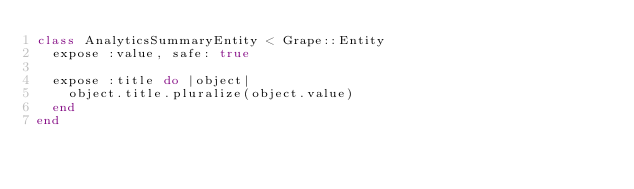Convert code to text. <code><loc_0><loc_0><loc_500><loc_500><_Ruby_>class AnalyticsSummaryEntity < Grape::Entity
  expose :value, safe: true

  expose :title do |object|
    object.title.pluralize(object.value)
  end
end
</code> 